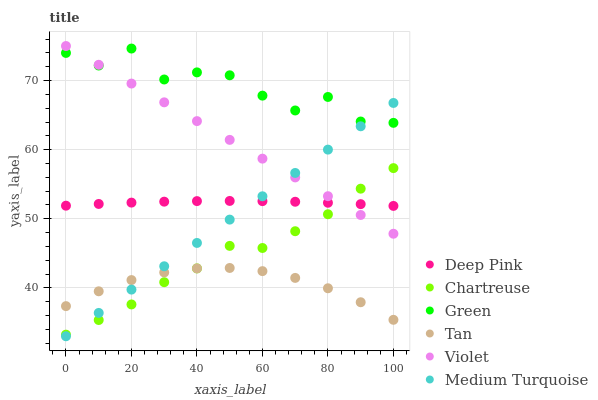Does Tan have the minimum area under the curve?
Answer yes or no. Yes. Does Green have the maximum area under the curve?
Answer yes or no. Yes. Does Chartreuse have the minimum area under the curve?
Answer yes or no. No. Does Chartreuse have the maximum area under the curve?
Answer yes or no. No. Is Violet the smoothest?
Answer yes or no. Yes. Is Green the roughest?
Answer yes or no. Yes. Is Chartreuse the smoothest?
Answer yes or no. No. Is Chartreuse the roughest?
Answer yes or no. No. Does Medium Turquoise have the lowest value?
Answer yes or no. Yes. Does Chartreuse have the lowest value?
Answer yes or no. No. Does Violet have the highest value?
Answer yes or no. Yes. Does Chartreuse have the highest value?
Answer yes or no. No. Is Chartreuse less than Green?
Answer yes or no. Yes. Is Green greater than Chartreuse?
Answer yes or no. Yes. Does Tan intersect Medium Turquoise?
Answer yes or no. Yes. Is Tan less than Medium Turquoise?
Answer yes or no. No. Is Tan greater than Medium Turquoise?
Answer yes or no. No. Does Chartreuse intersect Green?
Answer yes or no. No. 